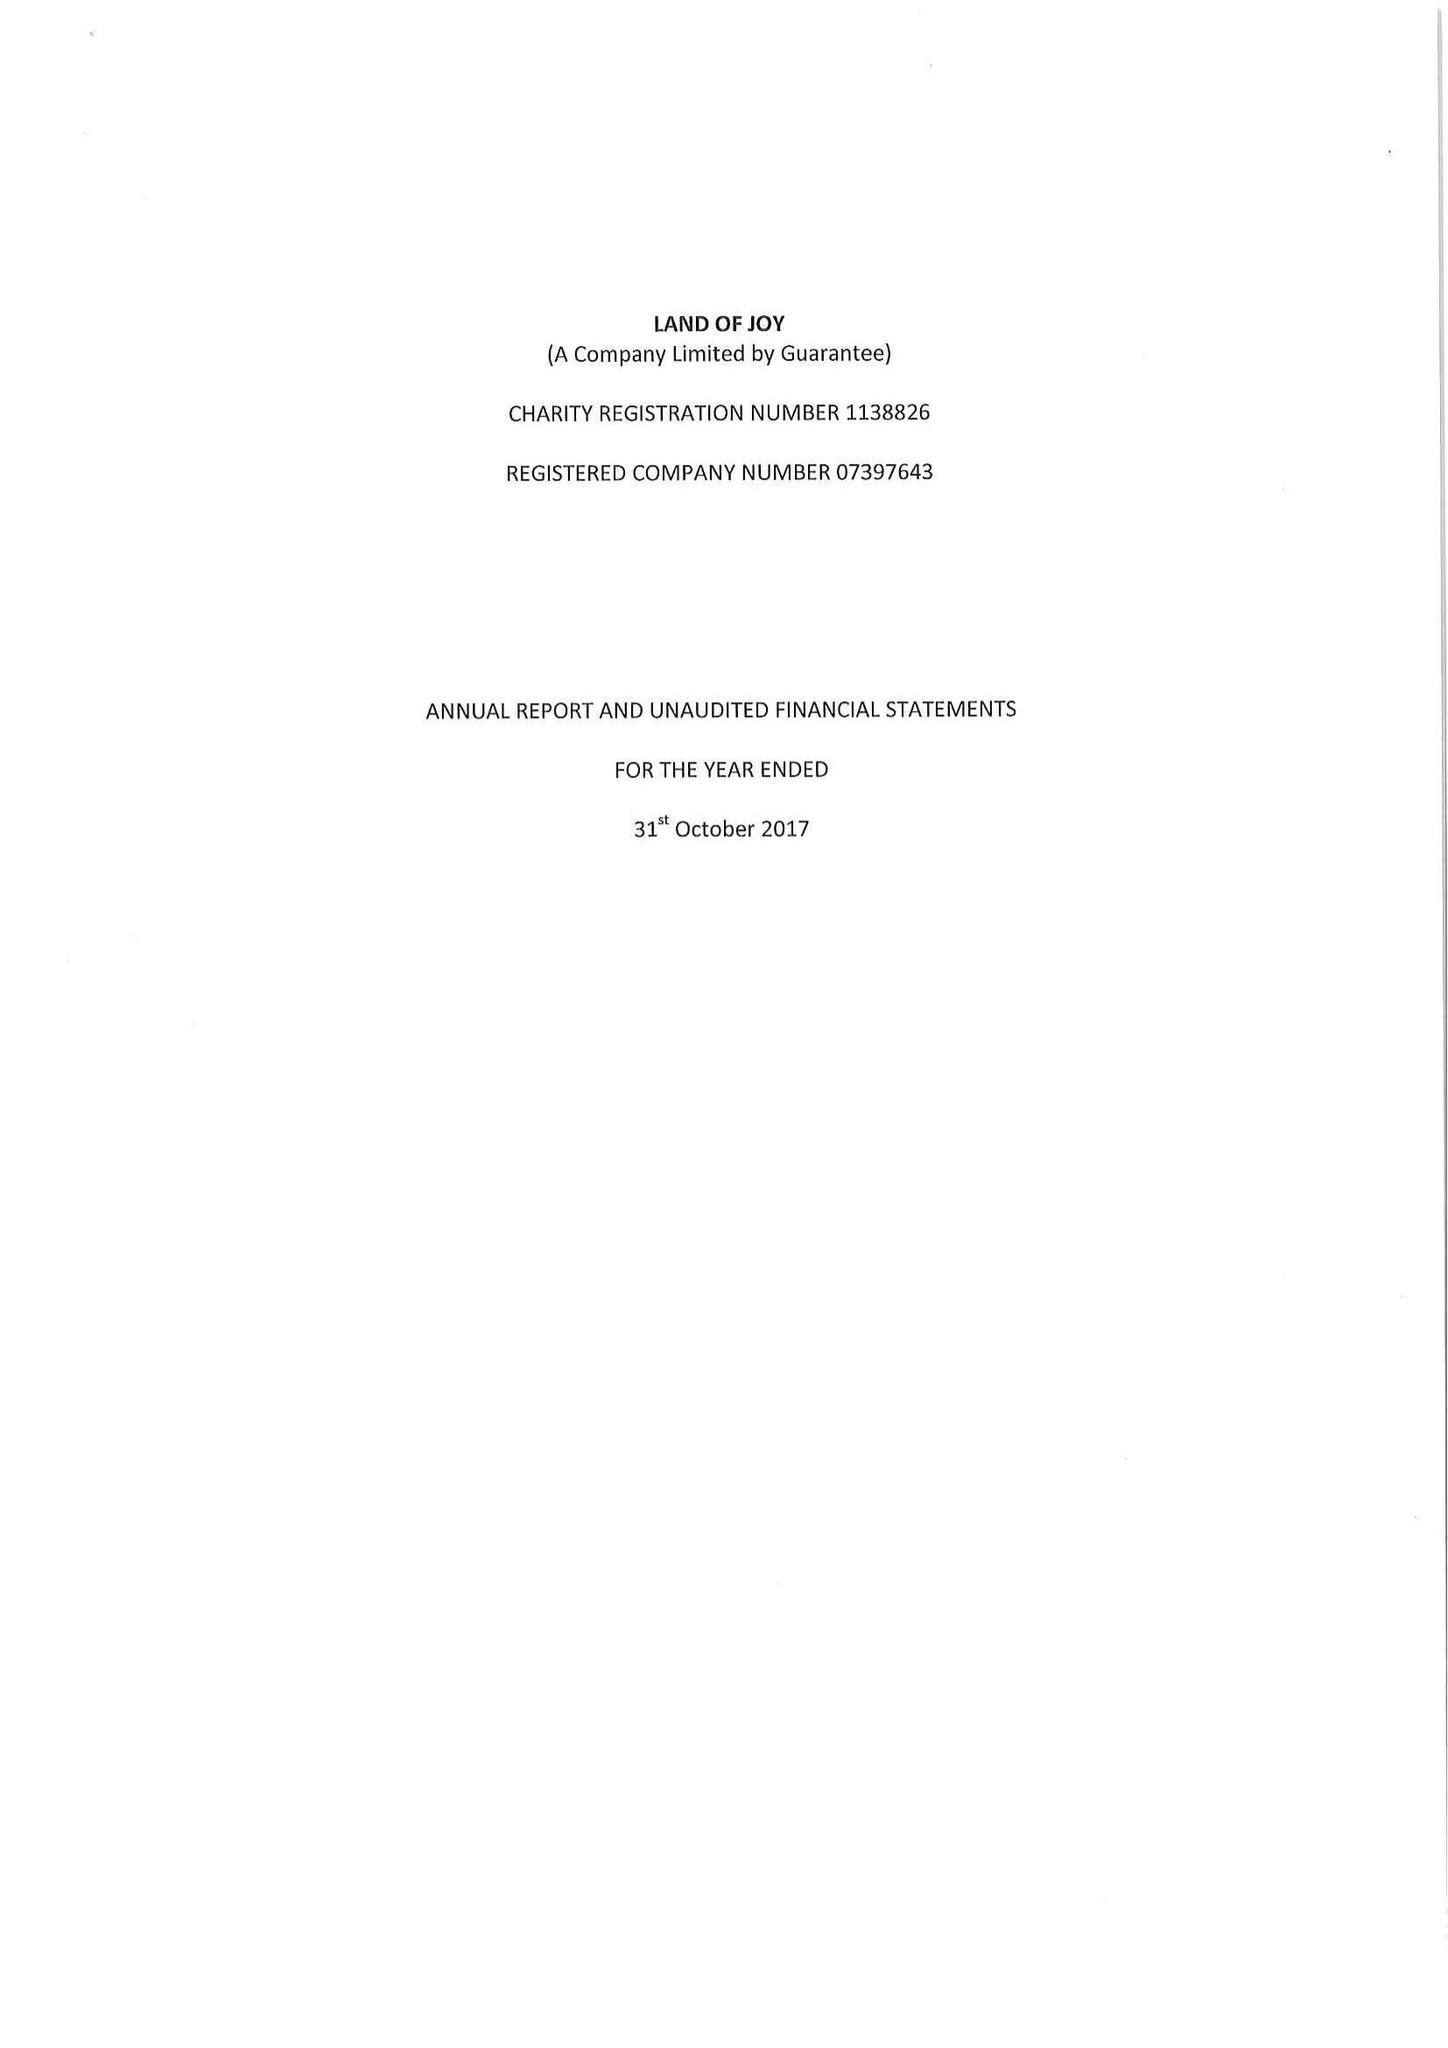What is the value for the spending_annually_in_british_pounds?
Answer the question using a single word or phrase. 87551.00 